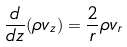Convert formula to latex. <formula><loc_0><loc_0><loc_500><loc_500>\frac { d } { d z } ( \rho { v } _ { z } ) = \frac { 2 } { r } \rho { v } _ { r }</formula> 